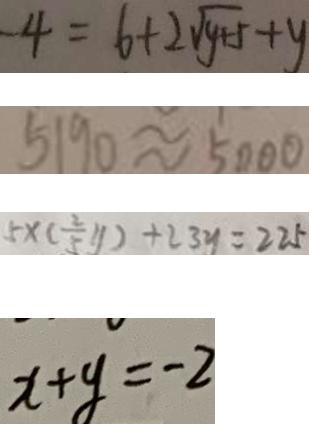Convert formula to latex. <formula><loc_0><loc_0><loc_500><loc_500>- 4 = 6 + 2 \sqrt { y + 5 } + y 
 5 1 9 0 \approx 5 0 0 0 
 5 \times ( \frac { 2 } { 5 } y ) + 2 3 y = 2 2 5 
 x + y = - 2</formula> 